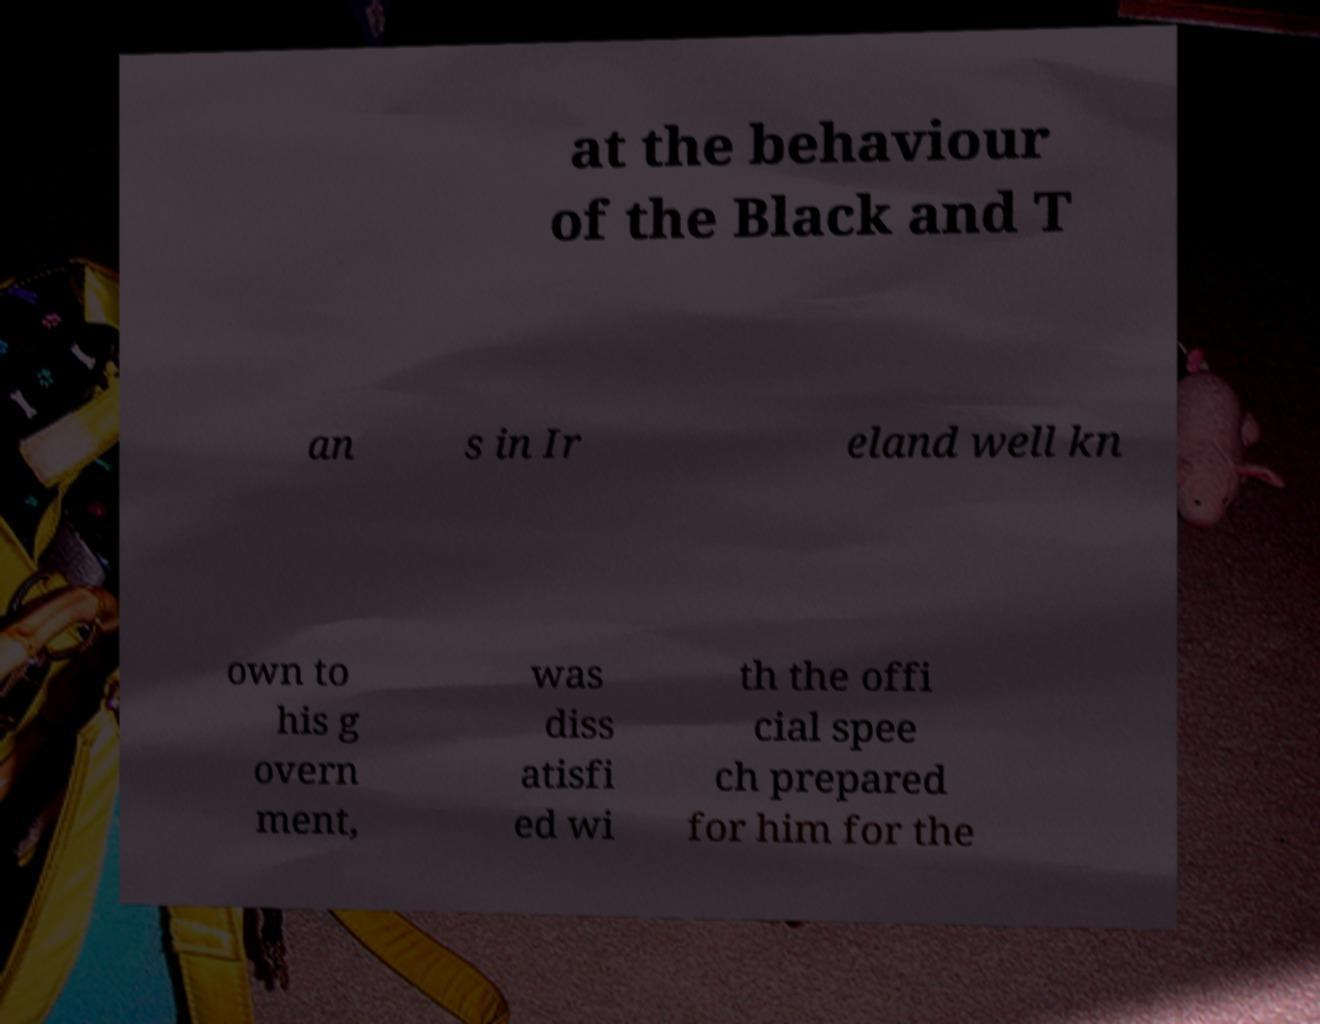For documentation purposes, I need the text within this image transcribed. Could you provide that? at the behaviour of the Black and T an s in Ir eland well kn own to his g overn ment, was diss atisfi ed wi th the offi cial spee ch prepared for him for the 